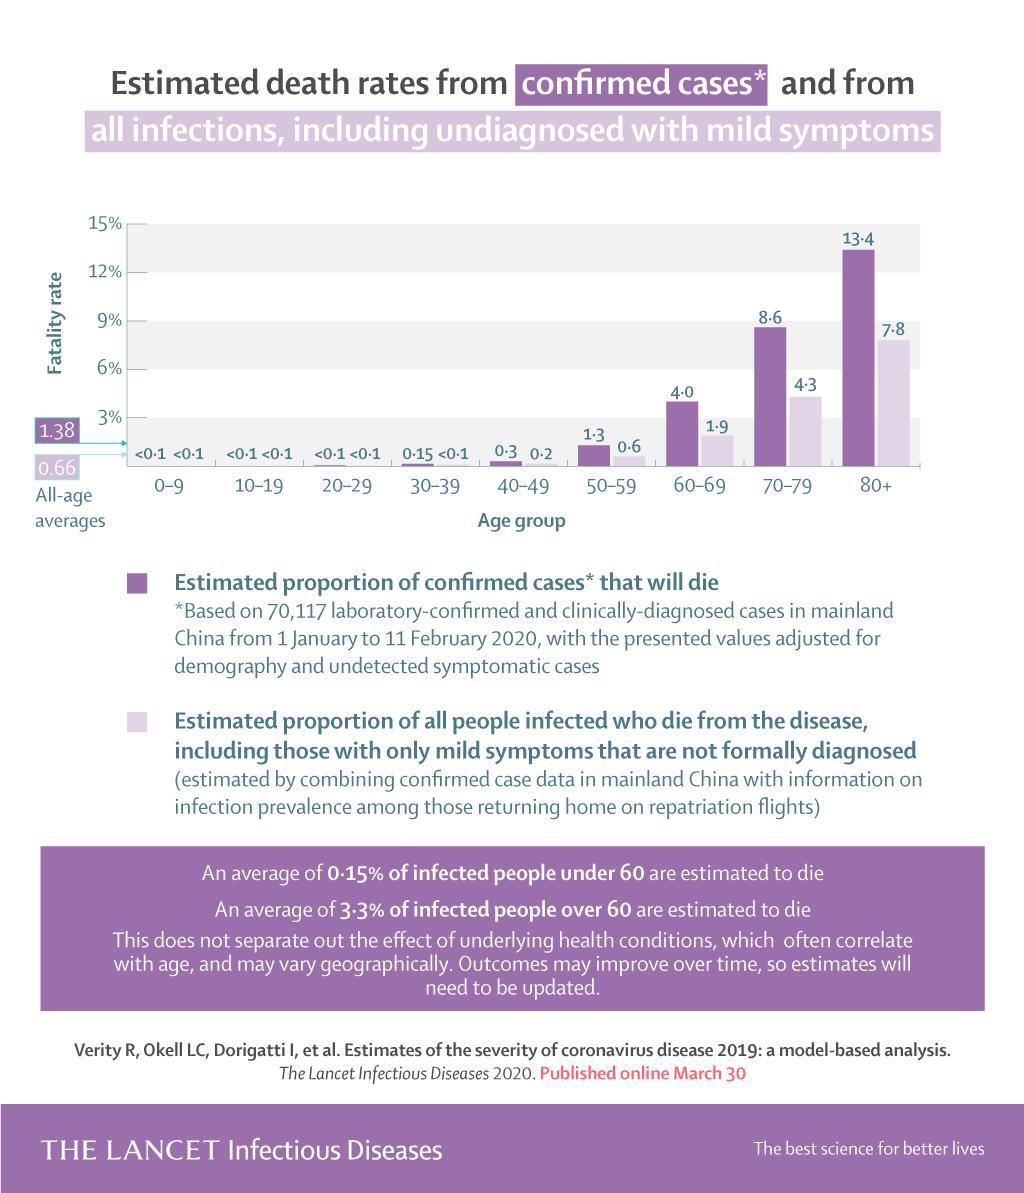What percent of confirmed cases above 60 years of age are estimated to die?
Answer the question with a short phrase. 26% 